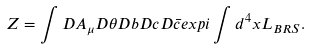<formula> <loc_0><loc_0><loc_500><loc_500>Z = \int D A _ { \mu } D \theta D b D c D \bar { c } e x p i \int d ^ { 4 } x L _ { B R S } .</formula> 